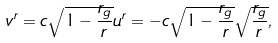Convert formula to latex. <formula><loc_0><loc_0><loc_500><loc_500>v ^ { r } = c \sqrt { 1 - \frac { r _ { g } } { r } } u ^ { r } = - c \sqrt { 1 - \frac { r _ { g } } { r } } \sqrt { \frac { r _ { g } } { r } } ,</formula> 